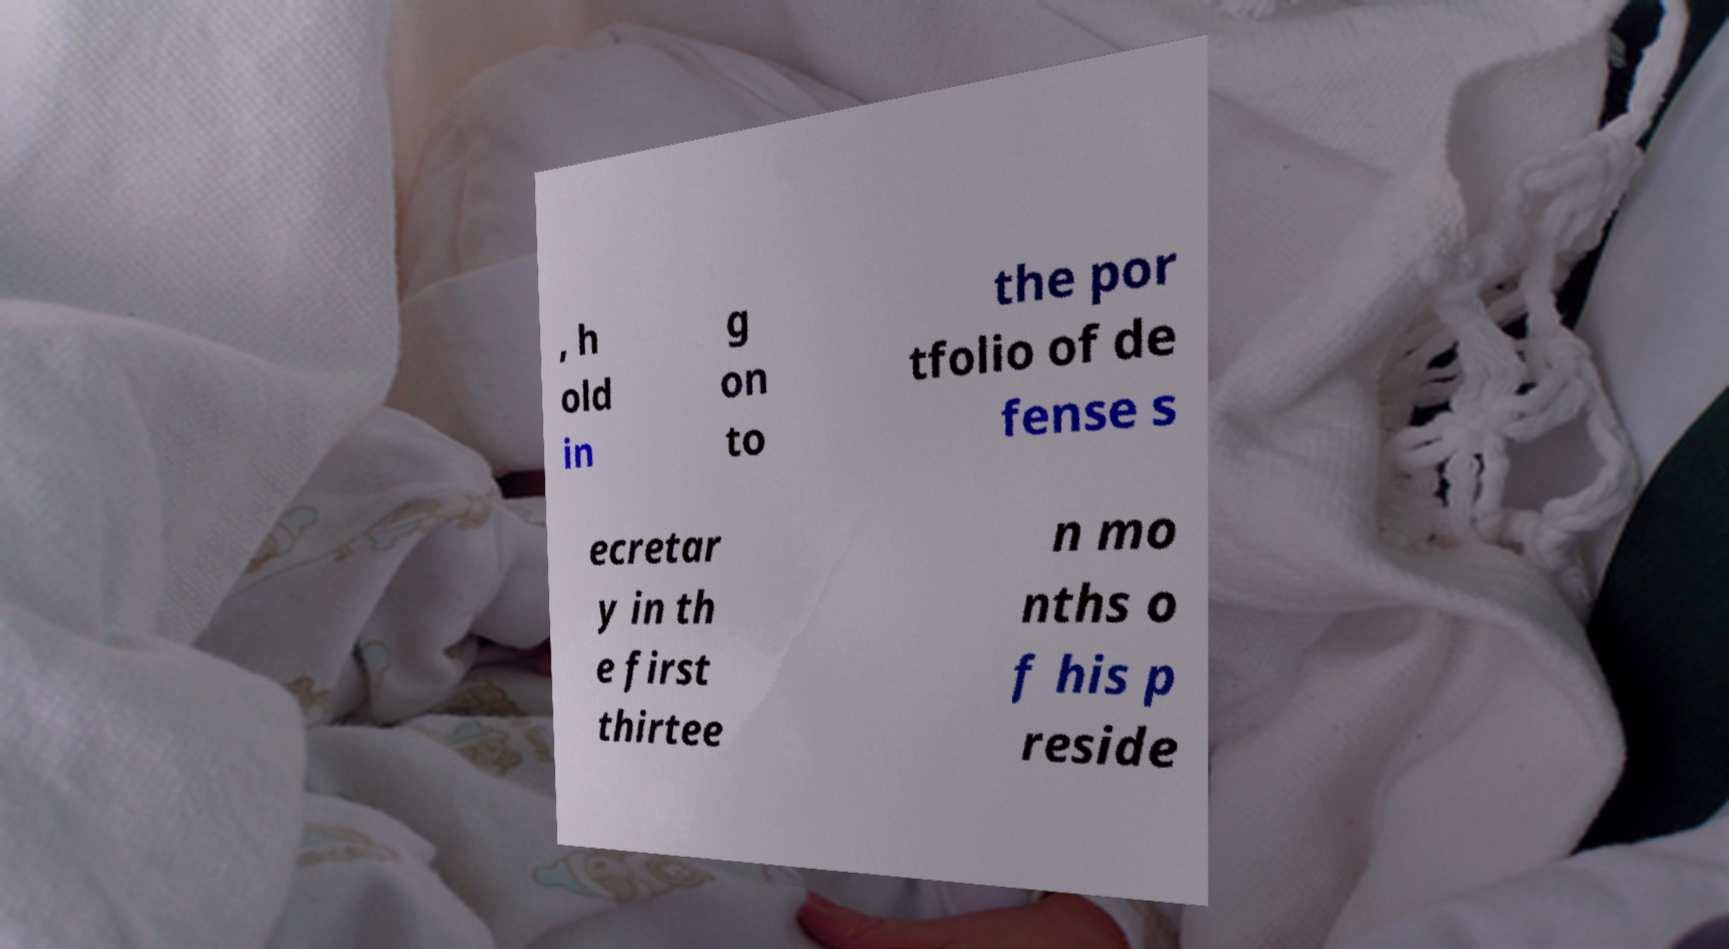Could you assist in decoding the text presented in this image and type it out clearly? , h old in g on to the por tfolio of de fense s ecretar y in th e first thirtee n mo nths o f his p reside 